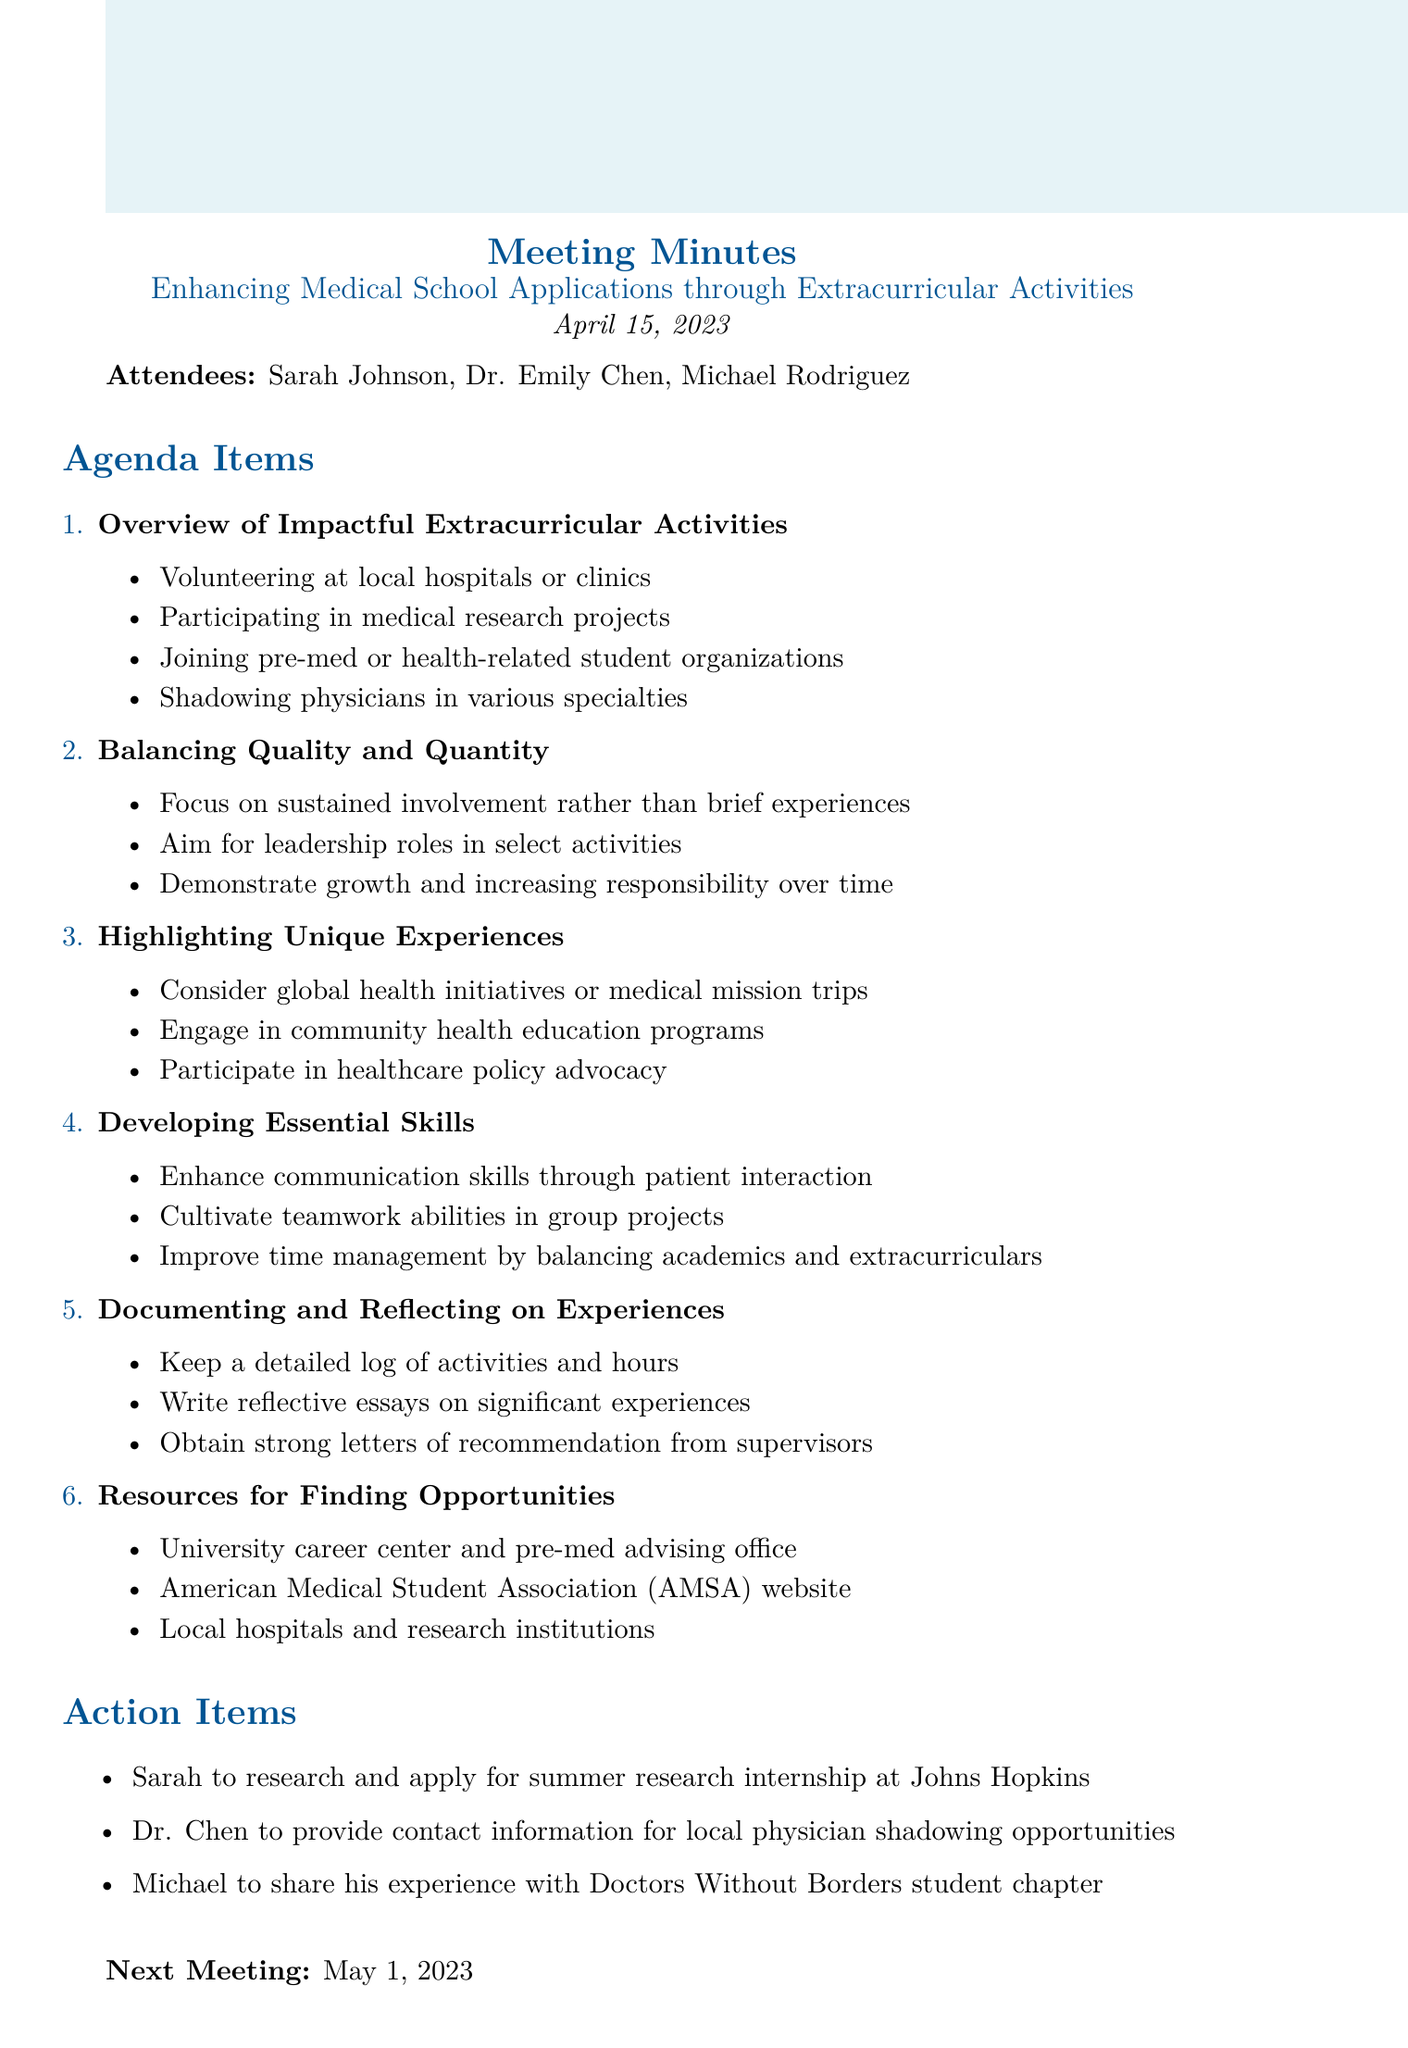What is the meeting title? The meeting title is listed prominently at the beginning of the document.
Answer: Enhancing Medical School Applications through Extracurricular Activities Who is the pre-med advisor present at the meeting? It is specified in the list of attendees who attended the meeting.
Answer: Dr. Emily Chen What date did the meeting take place? The date of the meeting is mentioned in the introduction section.
Answer: April 15, 2023 Which organization’s website is mentioned as a resource for finding opportunities? This information is found in the section on resources for finding opportunities.
Answer: American Medical Student Association What is one focus for enhancing extracurricular activities? This information is in the agenda item about balancing quality and quantity.
Answer: Sustained involvement What is an example of a unique experience to highlight? This can be found in the agenda item discussing unique experiences.
Answer: Global health initiatives How many action items were listed in the document? The number can be counted in the action items section of the document.
Answer: Three What is the date of the next meeting? The date of the next meeting is provided at the bottom of the document.
Answer: May 1, 2023 What is one skill that should be developed according to the meeting minutes? This is found in the section discussing essential skills.
Answer: Communication skills 